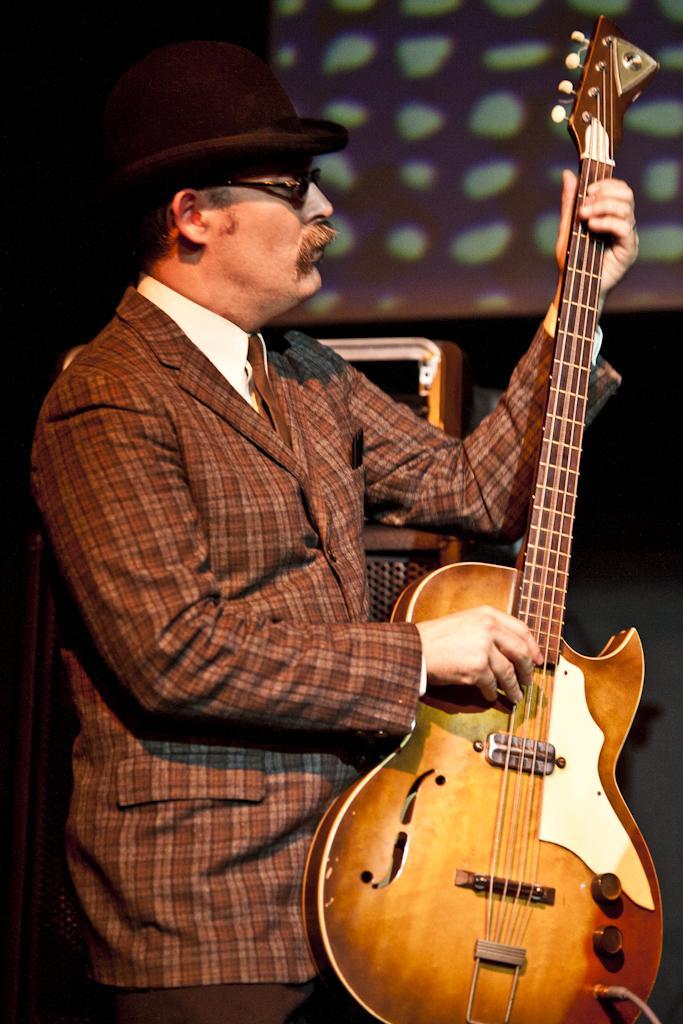How would you summarize this image in a sentence or two? In this image there is a man standing while holding a guitar in his hands. He is wearing a hat and he is wearing a coat which is in brown color. 